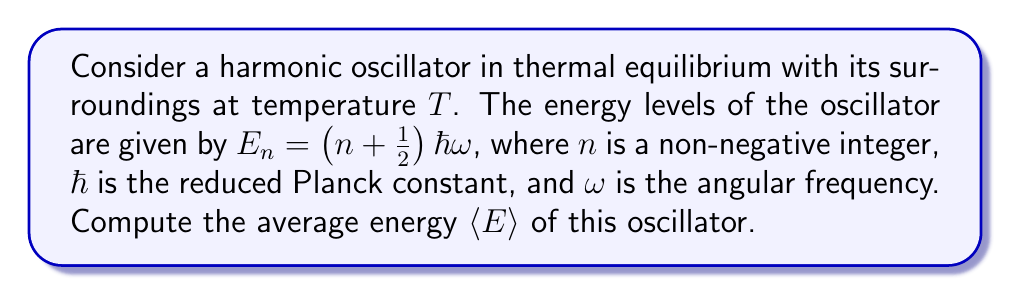Can you answer this question? To solve this problem, we'll follow these steps:

1) In statistical mechanics, the average energy is given by:
   $$\langle E \rangle = \frac{\sum_n E_n e^{-\beta E_n}}{\sum_n e^{-\beta E_n}}$$
   where $\beta = \frac{1}{k_B T}$, and $k_B$ is Boltzmann's constant.

2) Substitute $E_n = (n + \frac{1}{2})\hbar\omega$ into the equation:
   $$\langle E \rangle = \frac{\sum_n (n + \frac{1}{2})\hbar\omega e^{-\beta(n + \frac{1}{2})\hbar\omega}}{\sum_n e^{-\beta(n + \frac{1}{2})\hbar\omega}}$$

3) Factor out $e^{-\beta\frac{1}{2}\hbar\omega}$ from both numerator and denominator:
   $$\langle E \rangle = \frac{\hbar\omega e^{-\beta\frac{1}{2}\hbar\omega} \sum_n (n + \frac{1}{2}) e^{-\beta n\hbar\omega}}{e^{-\beta\frac{1}{2}\hbar\omega} \sum_n e^{-\beta n\hbar\omega}}$$

4) The sums in numerator and denominator are geometric series. Let $x = e^{-\beta\hbar\omega}$. Then:
   $$\sum_n e^{-\beta n\hbar\omega} = \sum_n x^n = \frac{1}{1-x}$$
   $$\sum_n n e^{-\beta n\hbar\omega} = \sum_n nx^n = \frac{x}{(1-x)^2}$$

5) Substituting these back:
   $$\langle E \rangle = \hbar\omega \left(\frac{\frac{1}{2} \cdot \frac{1}{1-x} + \frac{x}{(1-x)^2}}{\frac{1}{1-x}}\right)$$

6) Simplify:
   $$\langle E \rangle = \hbar\omega \left(\frac{1}{2} + \frac{x}{1-x}\right)$$

7) Substitute back $x = e^{-\beta\hbar\omega}$:
   $$\langle E \rangle = \hbar\omega \left(\frac{1}{2} + \frac{1}{e^{\beta\hbar\omega}-1}\right)$$

8) This can be written in terms of the average occupation number $\langle n \rangle$:
   $$\langle E \rangle = \hbar\omega \left(\frac{1}{2} + \langle n \rangle\right)$$
   where $\langle n \rangle = \frac{1}{e^{\beta\hbar\omega}-1}$ is the Bose-Einstein distribution.
Answer: $$\langle E \rangle = \hbar\omega \left(\frac{1}{2} + \frac{1}{e^{\hbar\omega/(k_B T)}-1}\right)$$ 